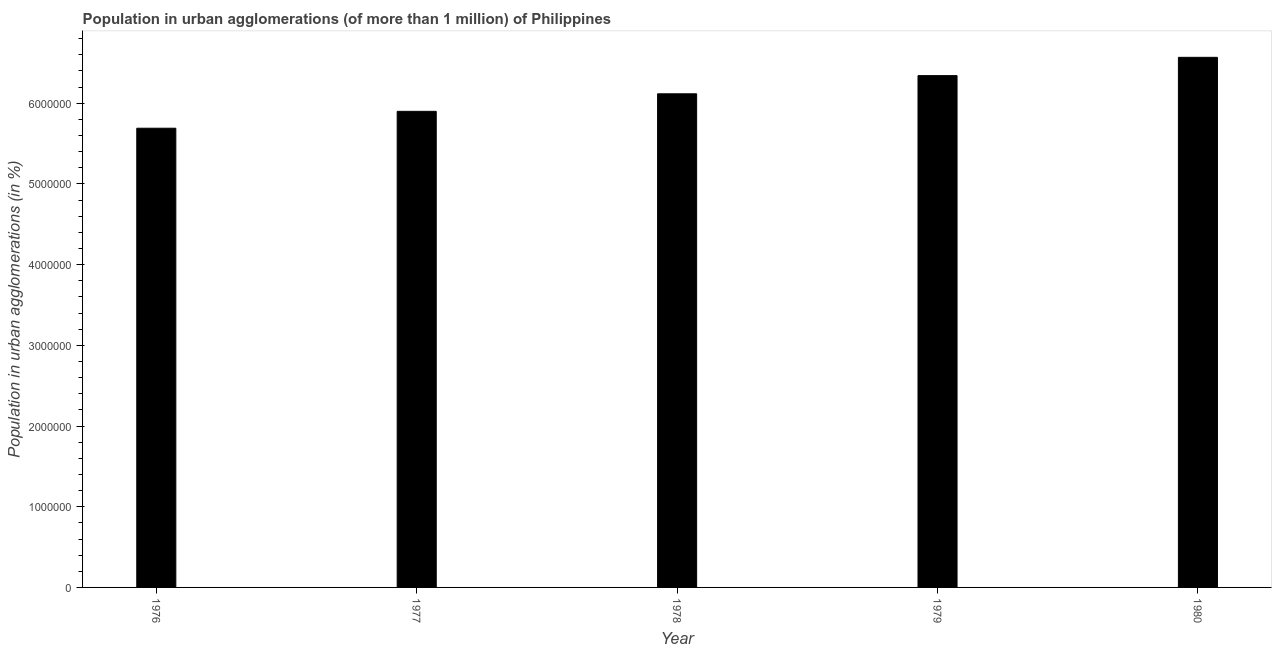Does the graph contain any zero values?
Make the answer very short. No. What is the title of the graph?
Offer a terse response. Population in urban agglomerations (of more than 1 million) of Philippines. What is the label or title of the X-axis?
Offer a very short reply. Year. What is the label or title of the Y-axis?
Ensure brevity in your answer.  Population in urban agglomerations (in %). What is the population in urban agglomerations in 1977?
Your answer should be very brief. 5.90e+06. Across all years, what is the maximum population in urban agglomerations?
Your answer should be compact. 6.57e+06. Across all years, what is the minimum population in urban agglomerations?
Ensure brevity in your answer.  5.69e+06. In which year was the population in urban agglomerations maximum?
Offer a terse response. 1980. In which year was the population in urban agglomerations minimum?
Your answer should be compact. 1976. What is the sum of the population in urban agglomerations?
Provide a short and direct response. 3.06e+07. What is the difference between the population in urban agglomerations in 1977 and 1978?
Give a very brief answer. -2.17e+05. What is the average population in urban agglomerations per year?
Keep it short and to the point. 6.12e+06. What is the median population in urban agglomerations?
Provide a short and direct response. 6.12e+06. Do a majority of the years between 1977 and 1976 (inclusive) have population in urban agglomerations greater than 4400000 %?
Your answer should be compact. No. Is the population in urban agglomerations in 1977 less than that in 1979?
Offer a very short reply. Yes. What is the difference between the highest and the second highest population in urban agglomerations?
Keep it short and to the point. 2.27e+05. What is the difference between the highest and the lowest population in urban agglomerations?
Make the answer very short. 8.78e+05. How many bars are there?
Keep it short and to the point. 5. How many years are there in the graph?
Make the answer very short. 5. What is the difference between two consecutive major ticks on the Y-axis?
Provide a short and direct response. 1.00e+06. Are the values on the major ticks of Y-axis written in scientific E-notation?
Your answer should be compact. No. What is the Population in urban agglomerations (in %) of 1976?
Give a very brief answer. 5.69e+06. What is the Population in urban agglomerations (in %) of 1977?
Provide a succinct answer. 5.90e+06. What is the Population in urban agglomerations (in %) in 1978?
Ensure brevity in your answer.  6.12e+06. What is the Population in urban agglomerations (in %) in 1979?
Your response must be concise. 6.34e+06. What is the Population in urban agglomerations (in %) of 1980?
Provide a succinct answer. 6.57e+06. What is the difference between the Population in urban agglomerations (in %) in 1976 and 1977?
Give a very brief answer. -2.09e+05. What is the difference between the Population in urban agglomerations (in %) in 1976 and 1978?
Offer a terse response. -4.26e+05. What is the difference between the Population in urban agglomerations (in %) in 1976 and 1979?
Offer a very short reply. -6.52e+05. What is the difference between the Population in urban agglomerations (in %) in 1976 and 1980?
Your response must be concise. -8.78e+05. What is the difference between the Population in urban agglomerations (in %) in 1977 and 1978?
Offer a very short reply. -2.17e+05. What is the difference between the Population in urban agglomerations (in %) in 1977 and 1979?
Ensure brevity in your answer.  -4.43e+05. What is the difference between the Population in urban agglomerations (in %) in 1977 and 1980?
Offer a terse response. -6.69e+05. What is the difference between the Population in urban agglomerations (in %) in 1978 and 1979?
Offer a terse response. -2.25e+05. What is the difference between the Population in urban agglomerations (in %) in 1978 and 1980?
Ensure brevity in your answer.  -4.52e+05. What is the difference between the Population in urban agglomerations (in %) in 1979 and 1980?
Your response must be concise. -2.27e+05. What is the ratio of the Population in urban agglomerations (in %) in 1976 to that in 1979?
Provide a succinct answer. 0.9. What is the ratio of the Population in urban agglomerations (in %) in 1976 to that in 1980?
Provide a short and direct response. 0.87. What is the ratio of the Population in urban agglomerations (in %) in 1977 to that in 1979?
Your answer should be very brief. 0.93. What is the ratio of the Population in urban agglomerations (in %) in 1977 to that in 1980?
Keep it short and to the point. 0.9. What is the ratio of the Population in urban agglomerations (in %) in 1978 to that in 1979?
Provide a short and direct response. 0.96. 